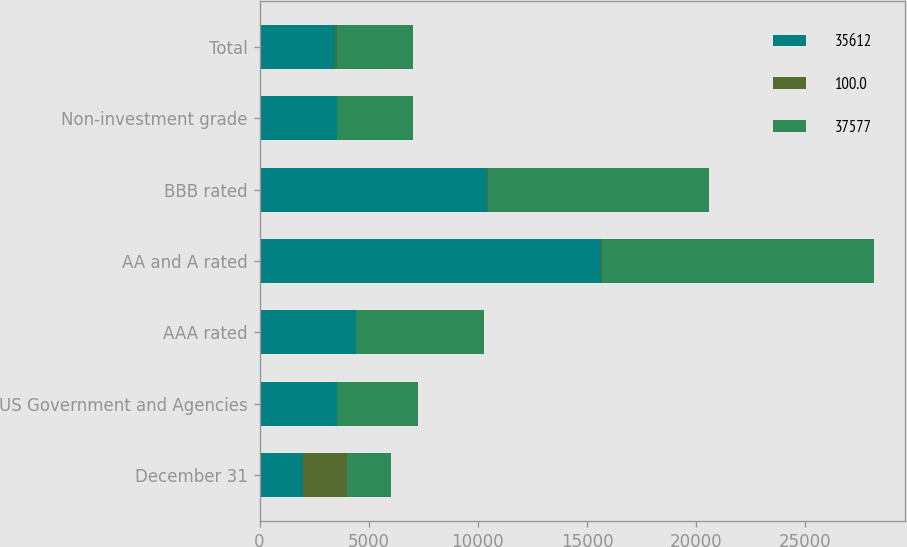<chart> <loc_0><loc_0><loc_500><loc_500><stacked_bar_chart><ecel><fcel>December 31<fcel>US Government and Agencies<fcel>AAA rated<fcel>AA and A rated<fcel>BBB rated<fcel>Non-investment grade<fcel>Total<nl><fcel>35612<fcel>2010<fcel>3534<fcel>4419<fcel>15665<fcel>10425<fcel>3534<fcel>3466<nl><fcel>100<fcel>2010<fcel>9.4<fcel>11.8<fcel>41.7<fcel>27.7<fcel>9.4<fcel>100<nl><fcel>37577<fcel>2009<fcel>3705<fcel>5855<fcel>12464<fcel>10122<fcel>3466<fcel>3466<nl></chart> 